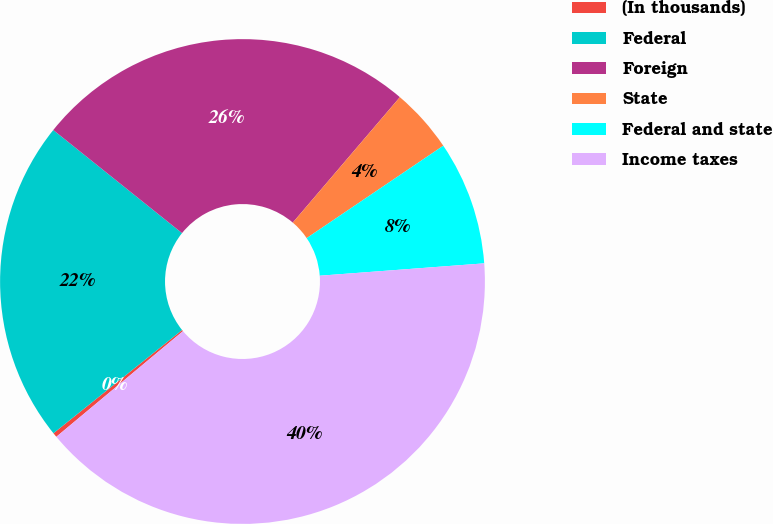Convert chart to OTSL. <chart><loc_0><loc_0><loc_500><loc_500><pie_chart><fcel>(In thousands)<fcel>Federal<fcel>Foreign<fcel>State<fcel>Federal and state<fcel>Income taxes<nl><fcel>0.3%<fcel>21.51%<fcel>25.5%<fcel>4.29%<fcel>8.27%<fcel>40.13%<nl></chart> 